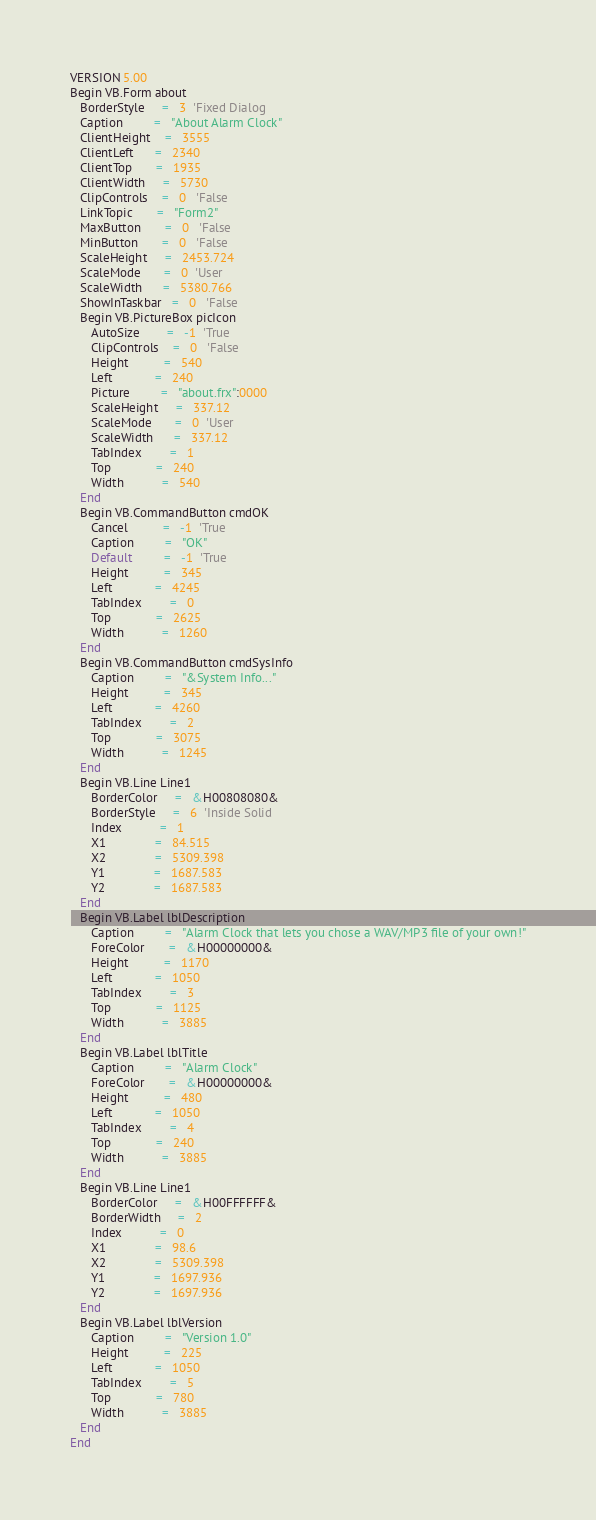Convert code to text. <code><loc_0><loc_0><loc_500><loc_500><_VisualBasic_>VERSION 5.00
Begin VB.Form about 
   BorderStyle     =   3  'Fixed Dialog
   Caption         =   "About Alarm Clock"
   ClientHeight    =   3555
   ClientLeft      =   2340
   ClientTop       =   1935
   ClientWidth     =   5730
   ClipControls    =   0   'False
   LinkTopic       =   "Form2"
   MaxButton       =   0   'False
   MinButton       =   0   'False
   ScaleHeight     =   2453.724
   ScaleMode       =   0  'User
   ScaleWidth      =   5380.766
   ShowInTaskbar   =   0   'False
   Begin VB.PictureBox picIcon 
      AutoSize        =   -1  'True
      ClipControls    =   0   'False
      Height          =   540
      Left            =   240
      Picture         =   "about.frx":0000
      ScaleHeight     =   337.12
      ScaleMode       =   0  'User
      ScaleWidth      =   337.12
      TabIndex        =   1
      Top             =   240
      Width           =   540
   End
   Begin VB.CommandButton cmdOK 
      Cancel          =   -1  'True
      Caption         =   "OK"
      Default         =   -1  'True
      Height          =   345
      Left            =   4245
      TabIndex        =   0
      Top             =   2625
      Width           =   1260
   End
   Begin VB.CommandButton cmdSysInfo 
      Caption         =   "&System Info..."
      Height          =   345
      Left            =   4260
      TabIndex        =   2
      Top             =   3075
      Width           =   1245
   End
   Begin VB.Line Line1 
      BorderColor     =   &H00808080&
      BorderStyle     =   6  'Inside Solid
      Index           =   1
      X1              =   84.515
      X2              =   5309.398
      Y1              =   1687.583
      Y2              =   1687.583
   End
   Begin VB.Label lblDescription 
      Caption         =   "Alarm Clock that lets you chose a WAV/MP3 file of your own!"
      ForeColor       =   &H00000000&
      Height          =   1170
      Left            =   1050
      TabIndex        =   3
      Top             =   1125
      Width           =   3885
   End
   Begin VB.Label lblTitle 
      Caption         =   "Alarm Clock"
      ForeColor       =   &H00000000&
      Height          =   480
      Left            =   1050
      TabIndex        =   4
      Top             =   240
      Width           =   3885
   End
   Begin VB.Line Line1 
      BorderColor     =   &H00FFFFFF&
      BorderWidth     =   2
      Index           =   0
      X1              =   98.6
      X2              =   5309.398
      Y1              =   1697.936
      Y2              =   1697.936
   End
   Begin VB.Label lblVersion 
      Caption         =   "Version 1.0"
      Height          =   225
      Left            =   1050
      TabIndex        =   5
      Top             =   780
      Width           =   3885
   End
End</code> 